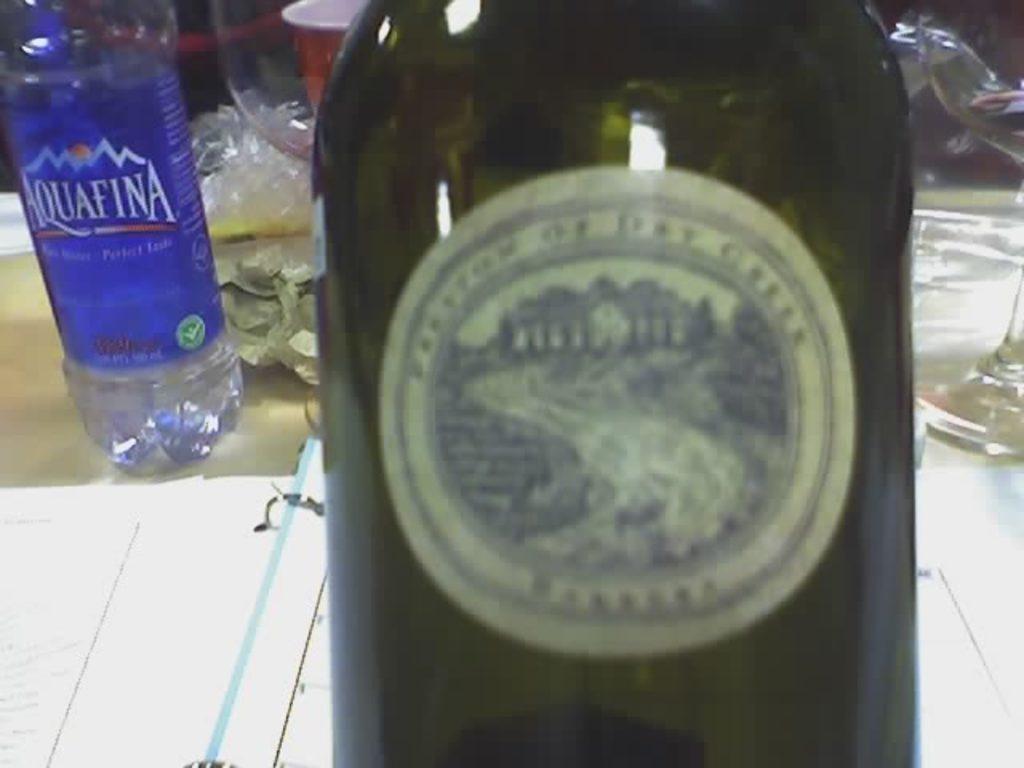Describe this image in one or two sentences. Here we can see a bottle of wine and besides that there is a bottle of water and there is a glass which are all placed on a table, here we can see a file of papers 